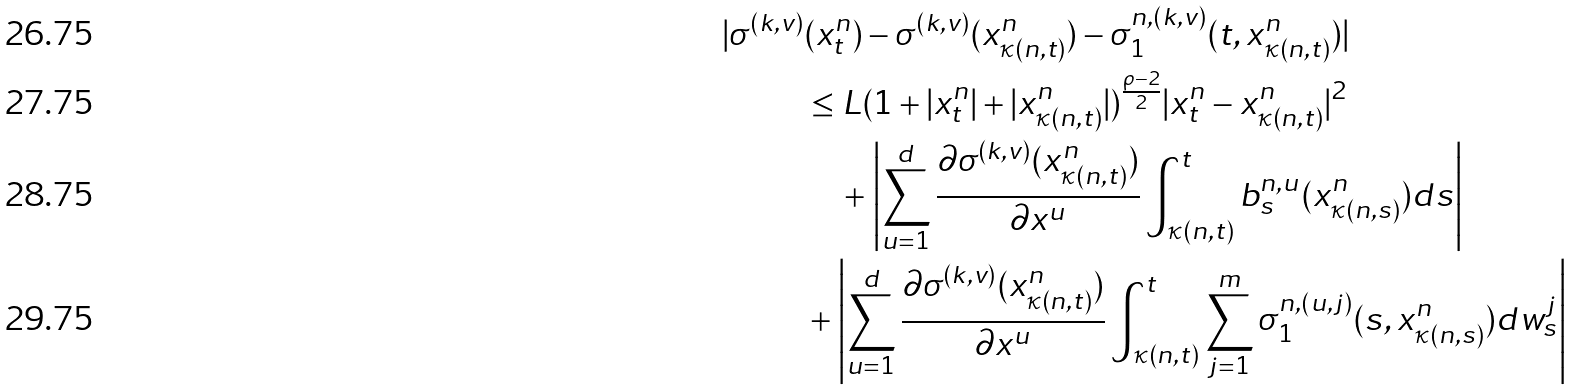<formula> <loc_0><loc_0><loc_500><loc_500>| \sigma ^ { ( k , v ) } & ( x _ { t } ^ { n } ) - \sigma ^ { ( k , v ) } ( x _ { \kappa ( n , t ) } ^ { n } ) - \sigma _ { 1 } ^ { n , ( k , v ) } ( t , x _ { \kappa ( n , t ) } ^ { n } ) | \\ & \leq L ( 1 + | x _ { t } ^ { n } | + | x _ { \kappa ( n , t ) } ^ { n } | ) ^ { \frac { \rho - 2 } { 2 } } | x _ { t } ^ { n } - x _ { \kappa ( n , t ) } ^ { n } | ^ { 2 } \\ & \quad + \left | \sum _ { u = 1 } ^ { d } \frac { \partial \sigma ^ { ( k , v ) } ( x _ { \kappa ( n , t ) } ^ { n } ) } { \partial x ^ { u } } \int _ { \kappa ( n , t ) } ^ { t } b _ { s } ^ { n , u } ( x _ { \kappa ( n , s ) } ^ { n } ) d s \right | \\ & + \left | \sum _ { u = 1 } ^ { d } \frac { \partial \sigma ^ { ( k , v ) } ( x _ { \kappa ( n , t ) } ^ { n } ) } { \partial x ^ { u } } \int _ { \kappa ( n , t ) } ^ { t } \sum _ { j = 1 } ^ { m } \sigma _ { 1 } ^ { n , ( u , j ) } ( s , x _ { \kappa ( n , s ) } ^ { n } ) d w _ { s } ^ { j } \right |</formula> 